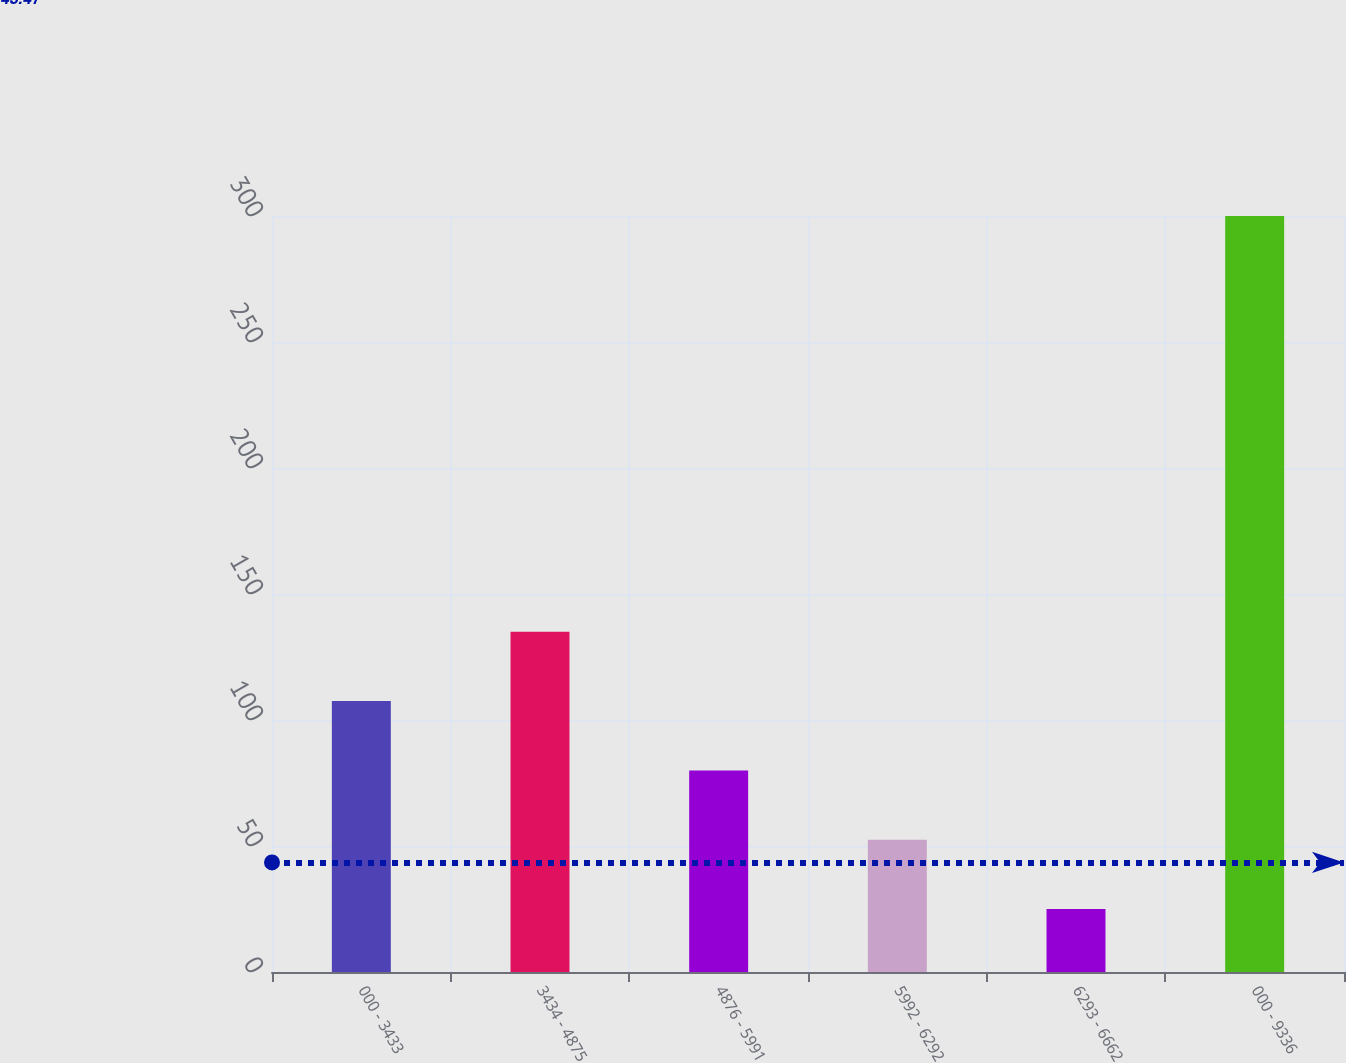Convert chart. <chart><loc_0><loc_0><loc_500><loc_500><bar_chart><fcel>000 - 3433<fcel>3434 - 4875<fcel>4876 - 5991<fcel>5992 - 6292<fcel>6293 - 6662<fcel>000 - 9336<nl><fcel>107.5<fcel>135<fcel>80<fcel>52.5<fcel>25<fcel>300<nl></chart> 